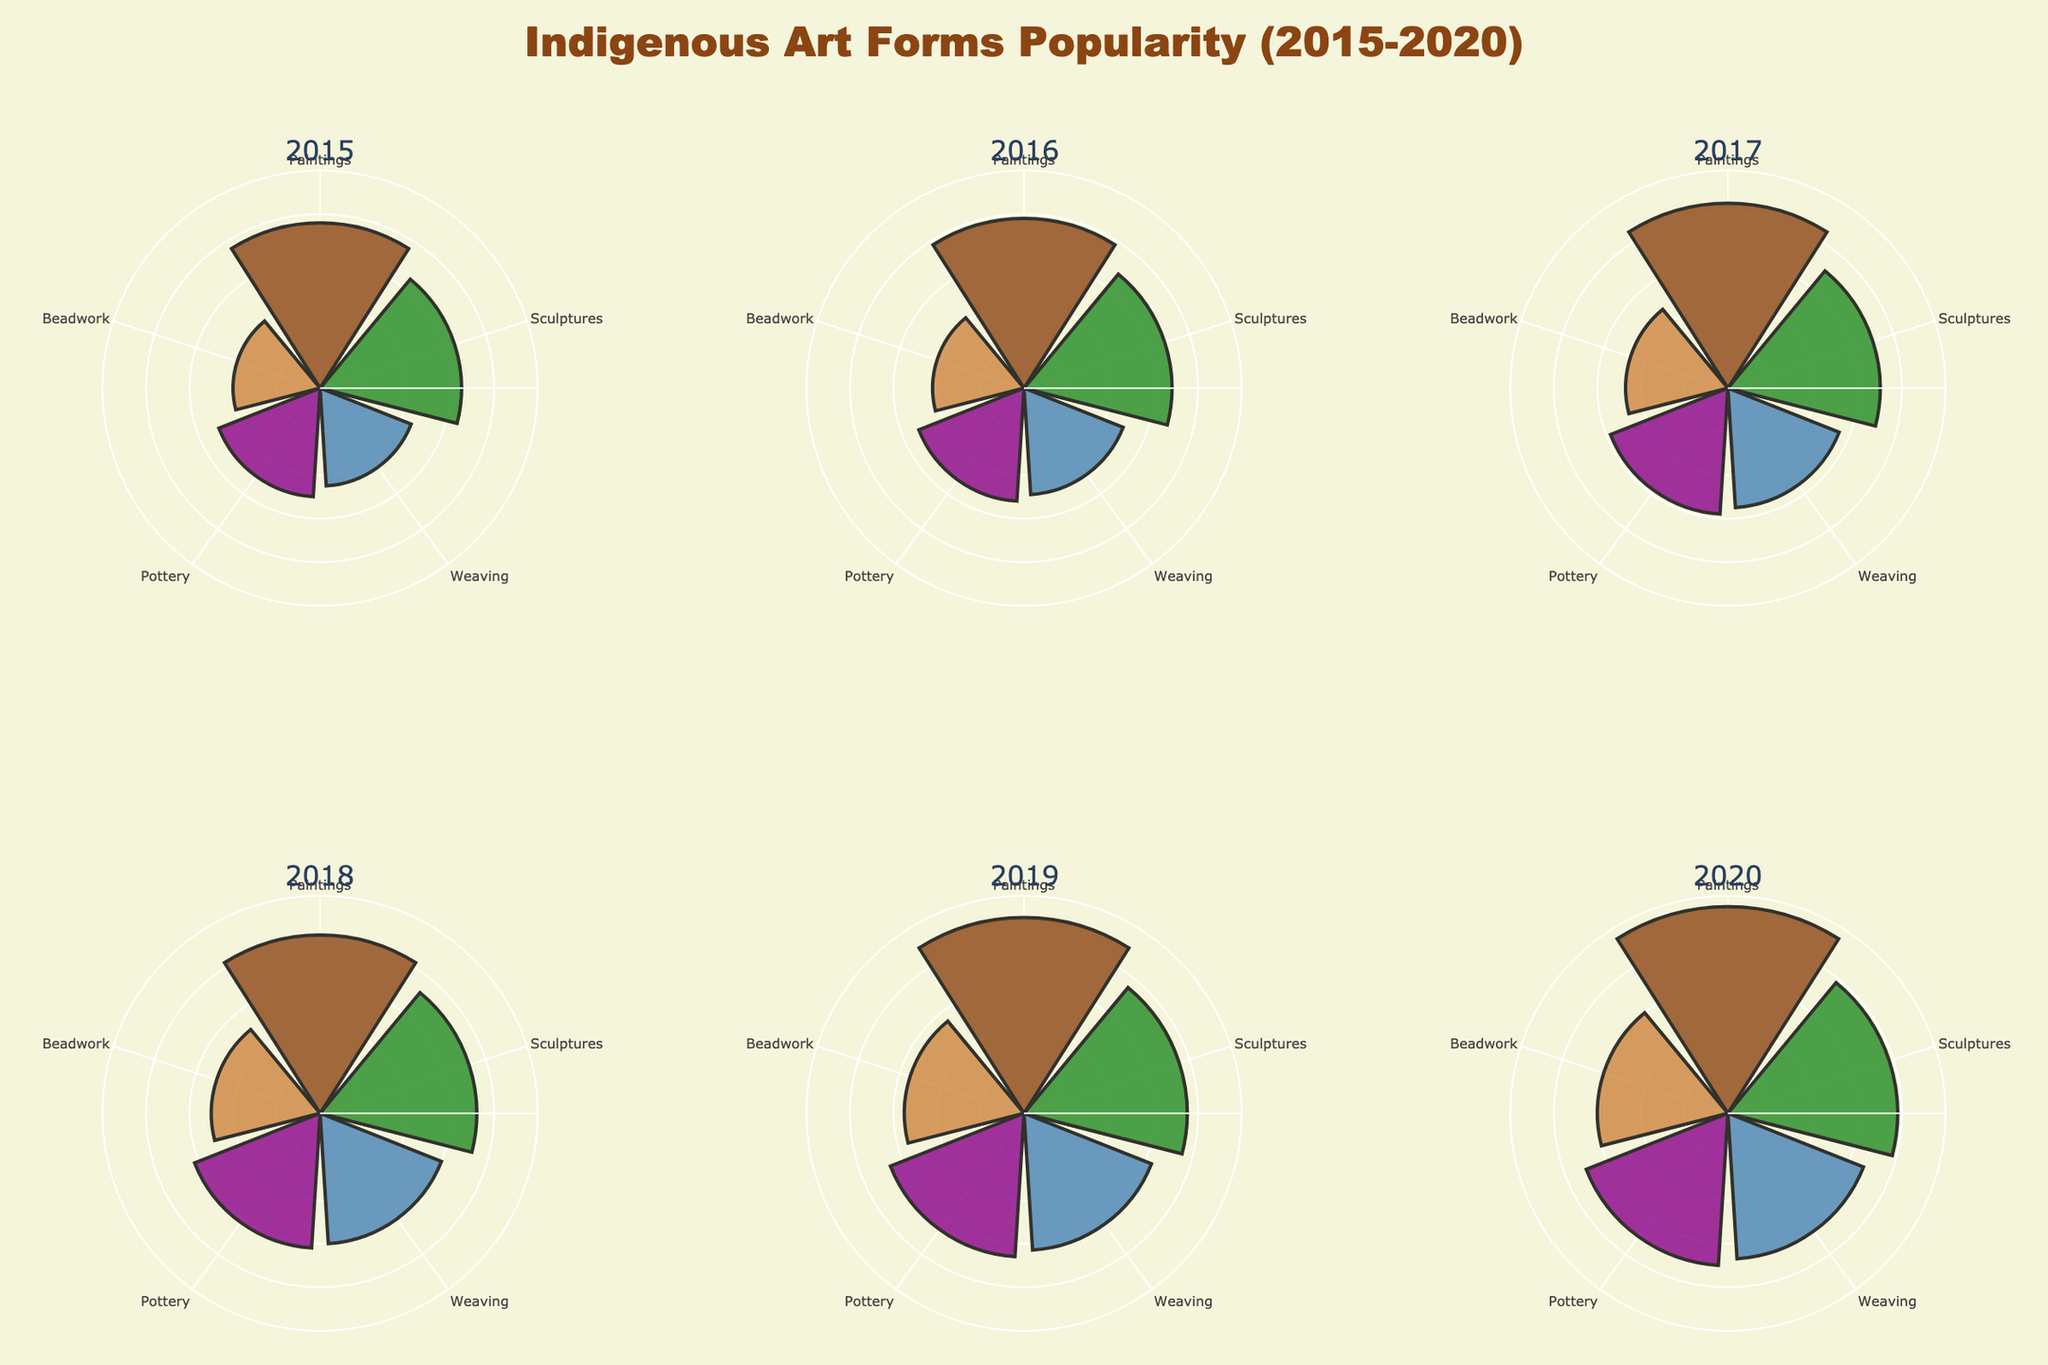How many art forms were tracked in each year? Each subplot representing a year includes the same number of art forms. By examining any subplot, it can be observed that there are five different types of Indigenous art forms listed.
Answer: 5 Which art forms showed an increase in popularity each year from 2015 to 2020? By examining each subplot from 2015 to 2020, it's evident that the popularity of Paintings, Sculptures, Weaving, Pottery, and Beadwork increases consistently over the years. This can be seen by the increasing length of the bars in each respective category over time.
Answer: All art forms Which year had the highest overall popularity for Paintings? By comparing the length of the bars for Paintings across all subplots, it's clear that 2020 had the longest bar for Paintings.
Answer: 2020 How did the popularity of Sculptures change from 2015 to 2020? Reviewing the bar lengths for Sculptures across the subplots shows an increase from 65 units in 2015 to 78 units in 2020. The bars in the respective categories grow each subsequent year.
Answer: Increased Which two art forms had the closest popularity values in 2019? By observing the subplot for 2019, Pottery (66) and Weaving (63) had the closest popularity values, as the lengths of these bars are nearly identical.
Answer: Pottery and Weaving In which year did Beadwork reach a popularity value of 60? The subplot for 2020 shows that Beadwork had a popularity value of 60, which is determined by the length of the bar for that category in that year.
Answer: 2020 What was the average popularity of Weaving from 2015 to 2020? Summing the popularity values of Weaving from 2015 to 2020 (45 + 49 + 55 + 60 + 63 + 67) gives 339. Dividing this total by the number of years (6) results in an average of 56.5.
Answer: 56.5 Which art form had the greatest increase in popularity between 2018 and 2019? Comparing the changes in the lengths of the bars for each art form between 2018 and 2019, Paintings show the greatest increase from 82 to 90, an increase of 8 units.
Answer: Paintings How does the radial axis range contribute to the clarity of the figure? The radial axis range is set from 0 to 100, providing a consistent scale for comparing popularity values across different years. This uniformity helps in easily identifying trends and variations by maintaining a standard reference point.
Answer: Consistent comparison 